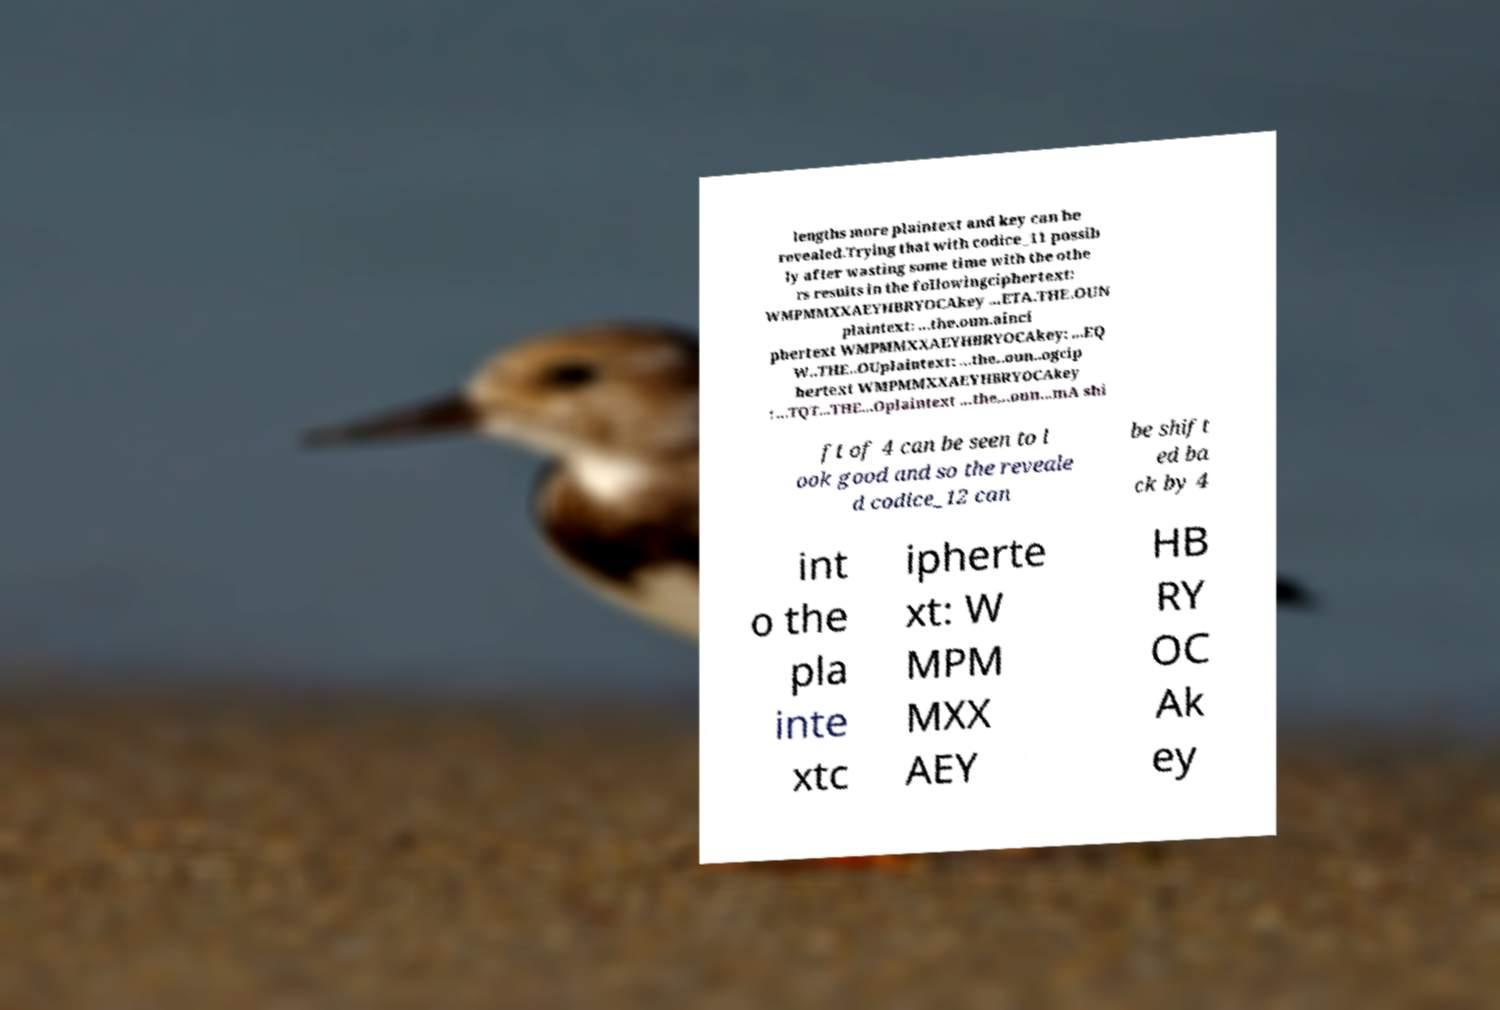What messages or text are displayed in this image? I need them in a readable, typed format. lengths more plaintext and key can be revealed.Trying that with codice_11 possib ly after wasting some time with the othe rs results in the followingciphertext: WMPMMXXAEYHBRYOCAkey ...ETA.THE.OUN plaintext: ...the.oun.ainci phertext WMPMMXXAEYHBRYOCAkey: ...EQ W..THE..OUplaintext: ...the..oun..ogcip hertext WMPMMXXAEYHBRYOCAkey : ...TQT...THE...Oplaintext ...the...oun...mA shi ft of 4 can be seen to l ook good and so the reveale d codice_12 can be shift ed ba ck by 4 int o the pla inte xtc ipherte xt: W MPM MXX AEY HB RY OC Ak ey 